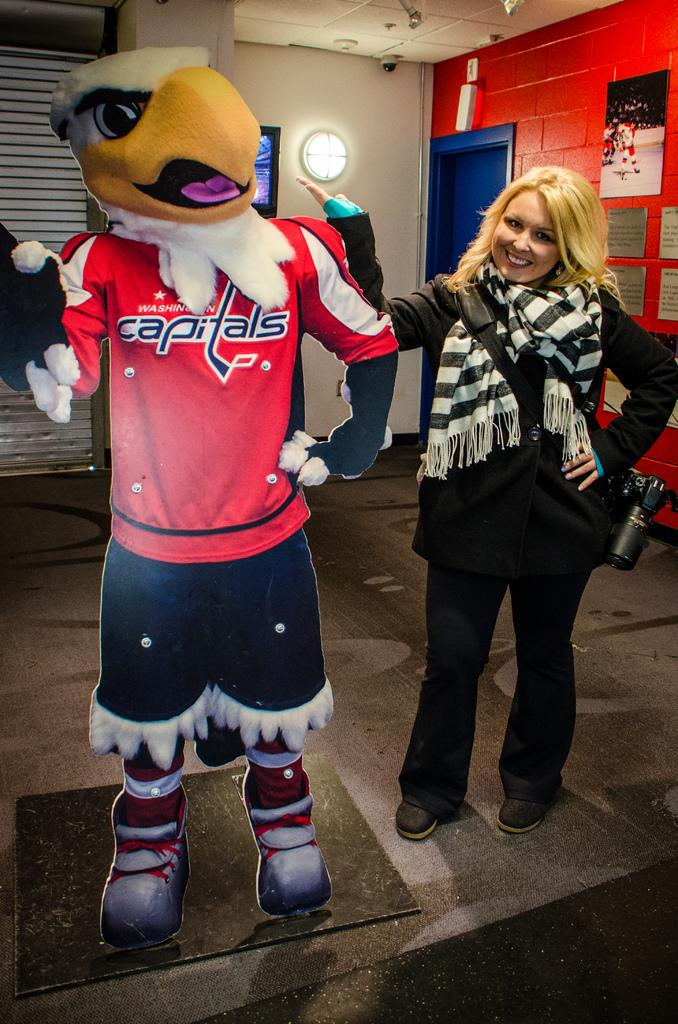<image>
Summarize the visual content of the image. A blonde woman posing next to a cutout of the Washington Capitals mascot 